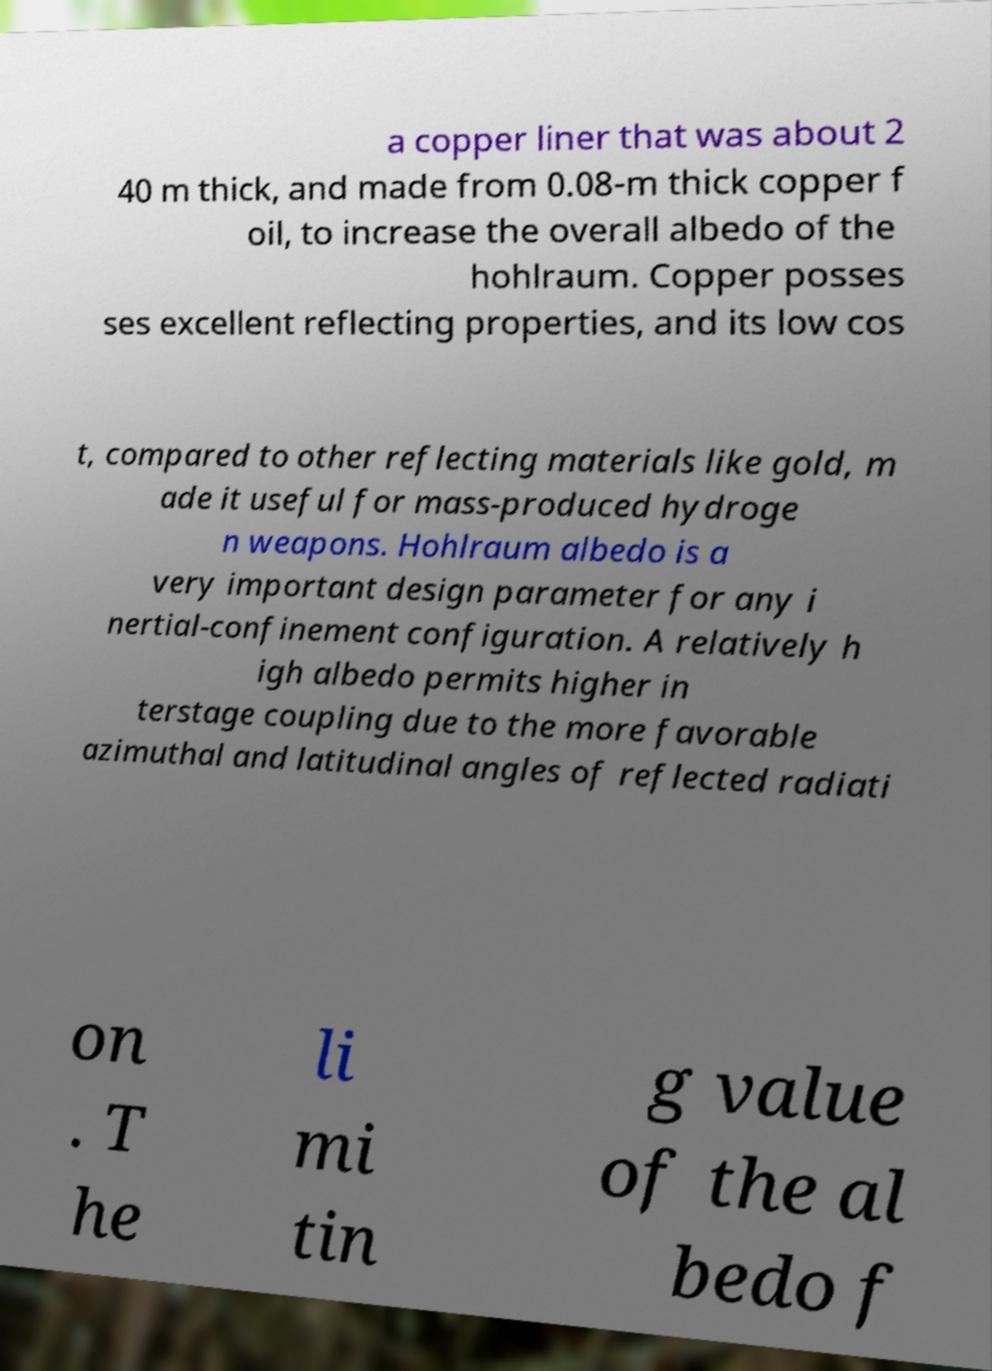There's text embedded in this image that I need extracted. Can you transcribe it verbatim? a copper liner that was about 2 40 m thick, and made from 0.08-m thick copper f oil, to increase the overall albedo of the hohlraum. Copper posses ses excellent reflecting properties, and its low cos t, compared to other reflecting materials like gold, m ade it useful for mass-produced hydroge n weapons. Hohlraum albedo is a very important design parameter for any i nertial-confinement configuration. A relatively h igh albedo permits higher in terstage coupling due to the more favorable azimuthal and latitudinal angles of reflected radiati on . T he li mi tin g value of the al bedo f 